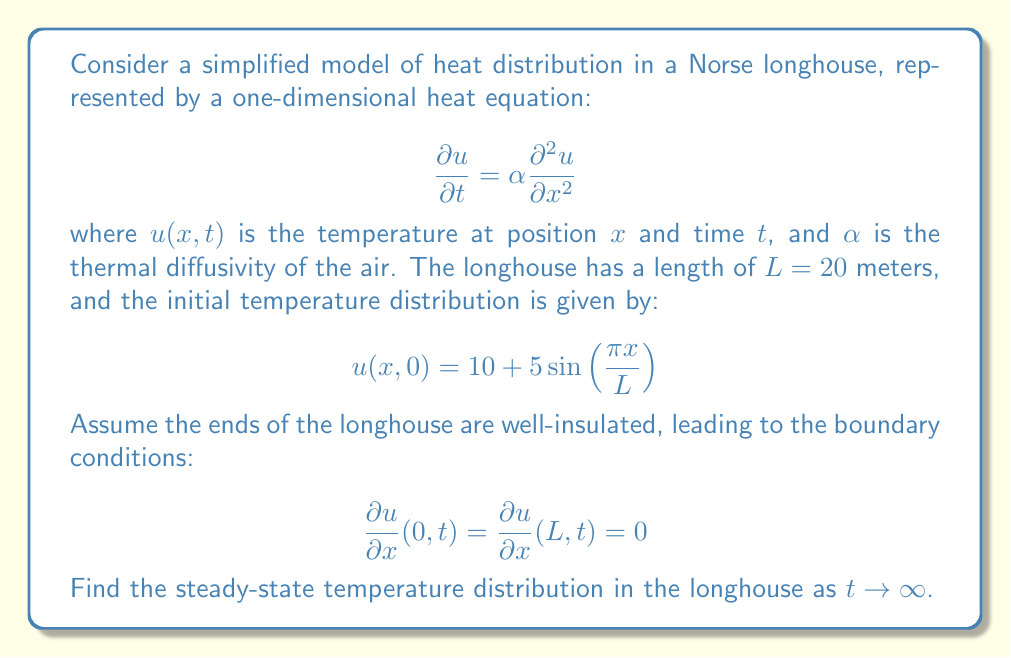What is the answer to this math problem? To solve this problem, we need to follow these steps:

1) First, we recognize that the steady-state solution is independent of time. This means we're looking for a solution where $\frac{\partial u}{\partial t} = 0$.

2) With this condition, our heat equation reduces to:

   $$0 = \alpha \frac{\partial^2 u}{\partial x^2}$$

3) This implies that $\frac{\partial^2 u}{\partial x^2} = 0$, which means $u(x)$ must be a linear function of $x$.

4) The general solution is therefore:

   $$u(x) = Ax + B$$

   where $A$ and $B$ are constants we need to determine.

5) Now we apply the boundary conditions. For the left boundary:

   $$\frac{\partial u}{\partial x}(0,t) = 0 \implies A = 0$$

6) For the right boundary:

   $$\frac{\partial u}{\partial x}(L,t) = 0 \implies A = 0$$

   This confirms our result from step 5.

7) With $A = 0$, our solution becomes $u(x) = B$, a constant.

8) To determine $B$, we use the principle of conservation of energy. The total heat in the system must remain constant over time. We can express this mathematically as:

   $$\int_0^L u(x,0) dx = \int_0^L u(x,\infty) dx$$

9) The left side of this equation is:

   $$\int_0^L \left(10 + 5\sin\left(\frac{\pi x}{L}\right)\right) dx = 10L + \frac{5L}{\pi}[- \cos(\pi) + \cos(0)] = 10L$$

10) The right side is simply:

    $$\int_0^L B dx = BL$$

11) Equating these:

    $$10L = BL \implies B = 10$$

Therefore, the steady-state temperature distribution is a constant 10 degrees throughout the longhouse.
Answer: The steady-state temperature distribution in the longhouse as $t \to \infty$ is:

$$u(x) = 10$$

This means the temperature will eventually become uniform at 10 degrees throughout the longhouse. 